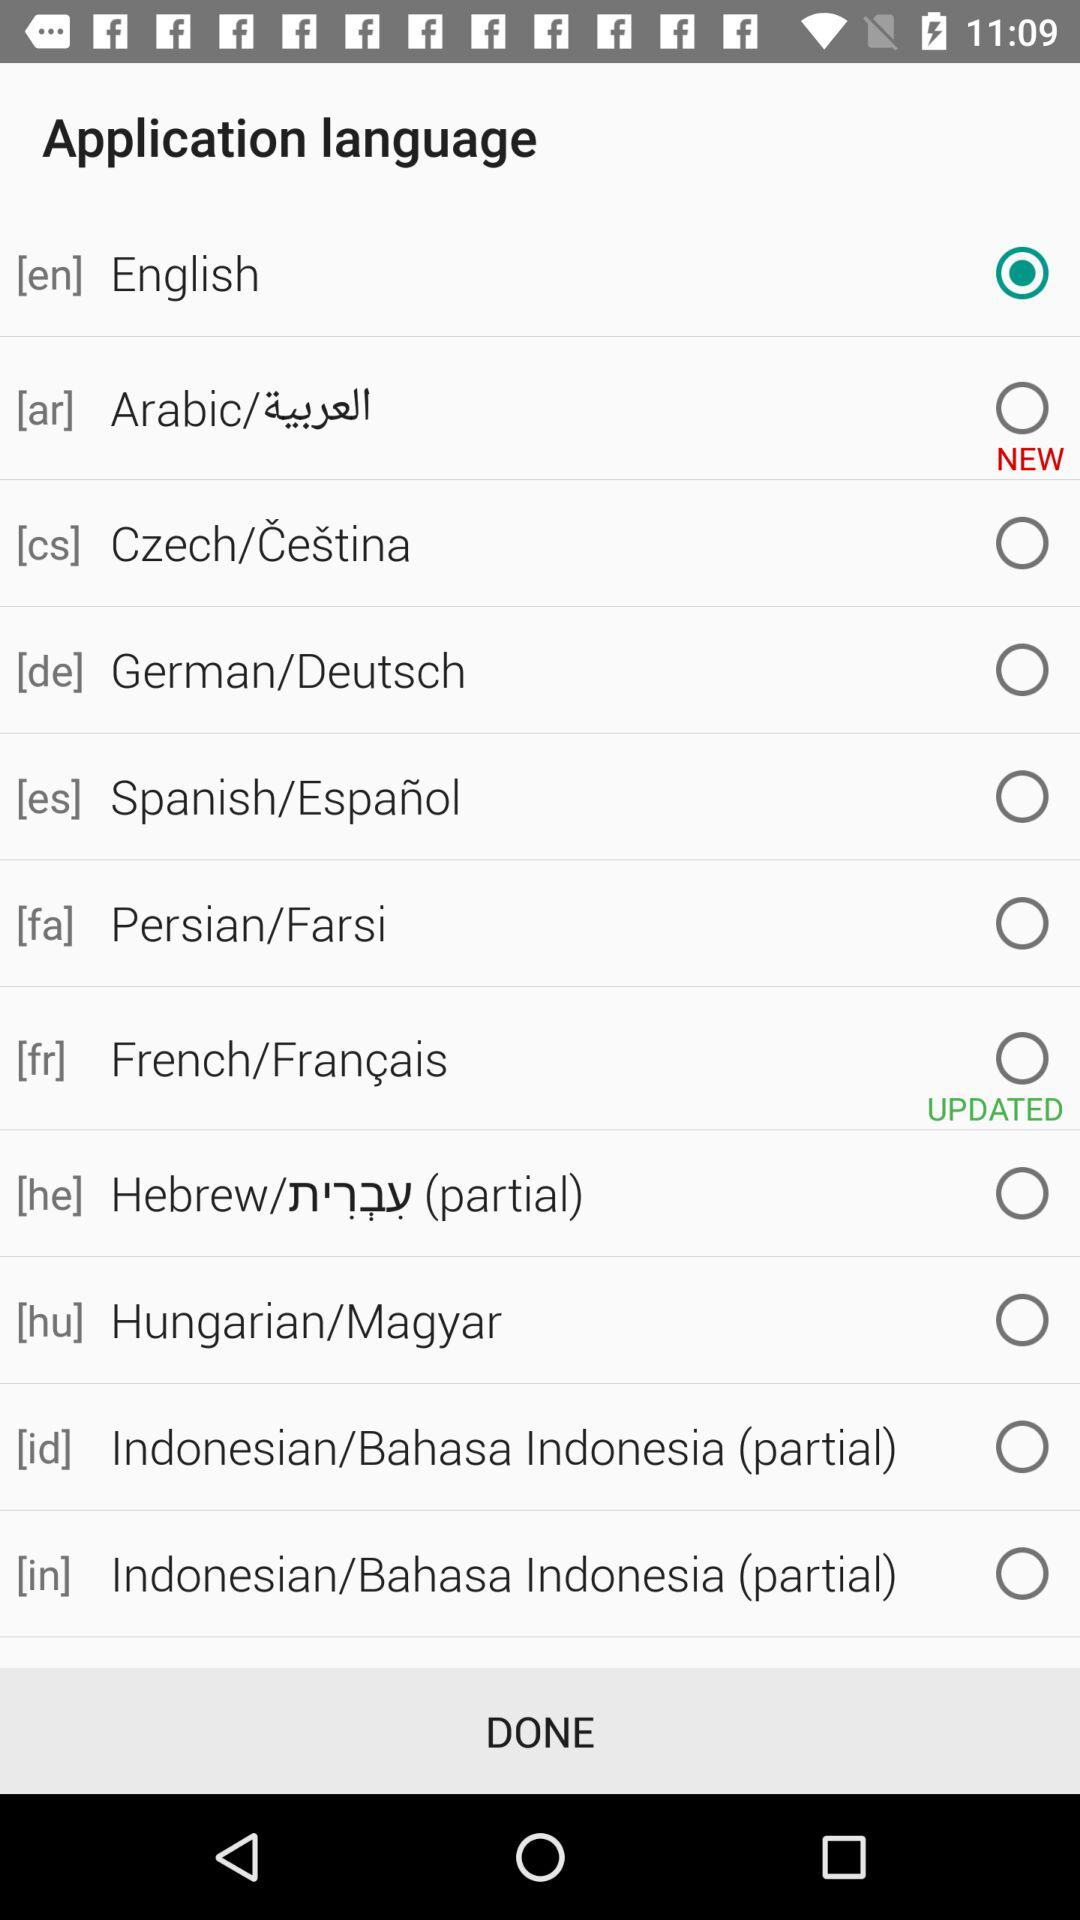Which language is selected? The selected language is English. 